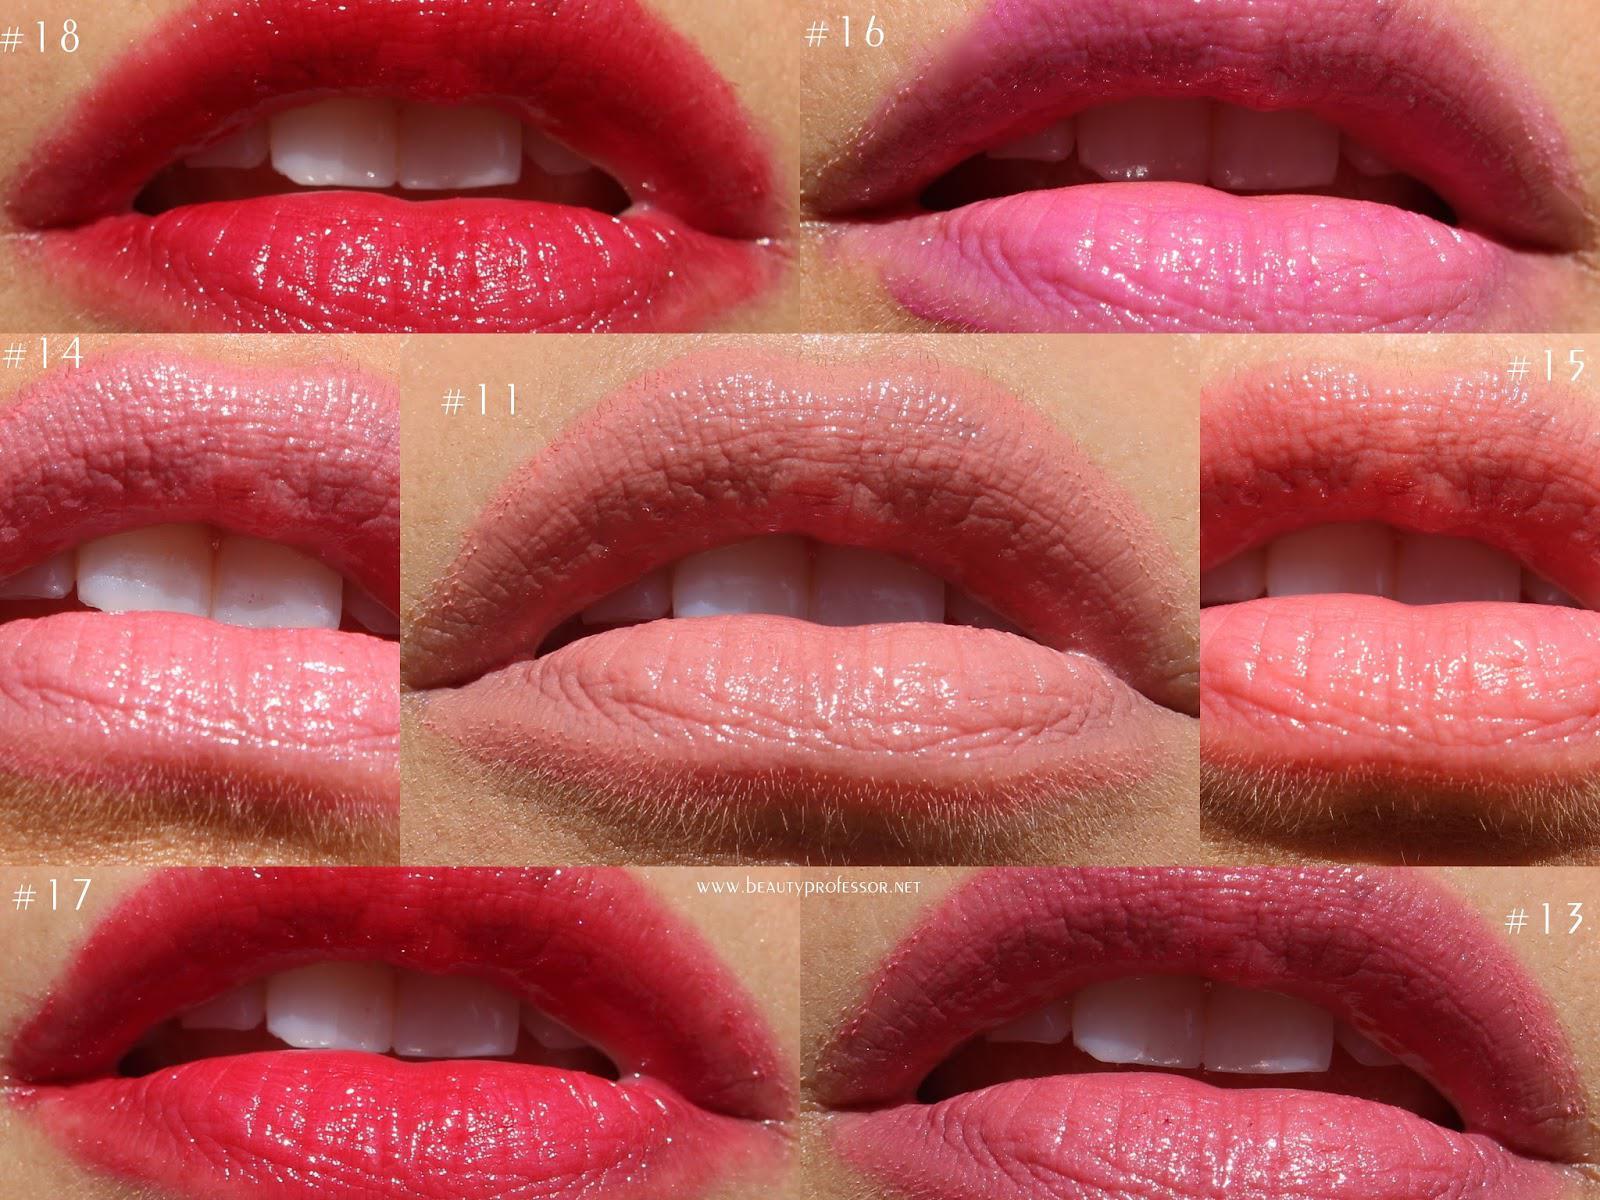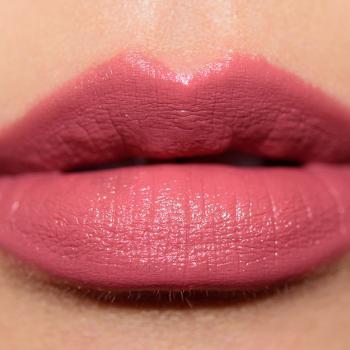The first image is the image on the left, the second image is the image on the right. Evaluate the accuracy of this statement regarding the images: "The image on the right shows on pair of lips wearing makeup.". Is it true? Answer yes or no. Yes. The first image is the image on the left, the second image is the image on the right. For the images shown, is this caption "There are more than six pairs of lips in total." true? Answer yes or no. Yes. 